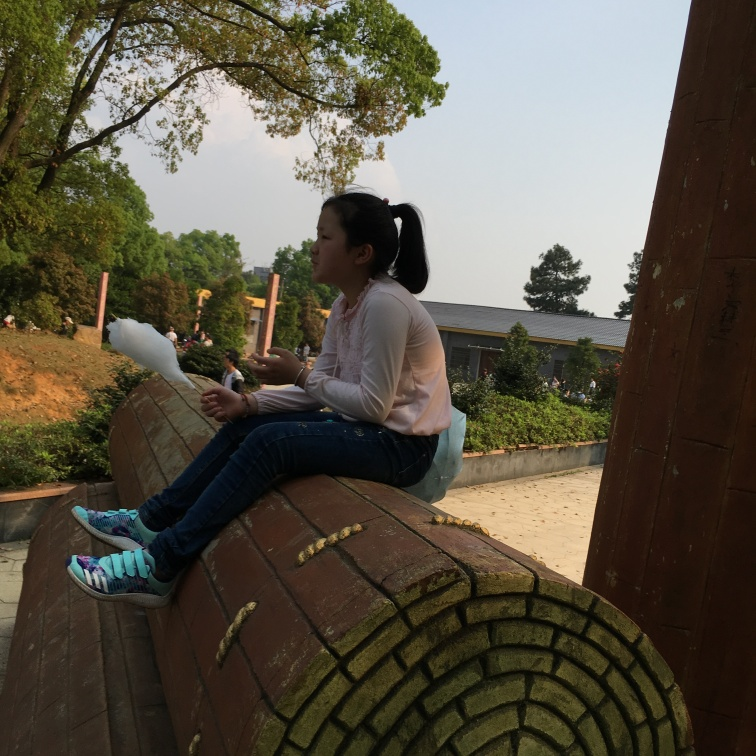Is the exposure of the photo satisfactory? The exposure of the photo is not ideal; it's slightly underexposed, resulting in a loss of detail in the shaded areas. For a more balanced photo, slight exposure compensation could bring out more detail without losing the mood captured in the softer light. This adjustment would ensure that the subject is well-lit while still preserving the natural ambiance of the scene. 